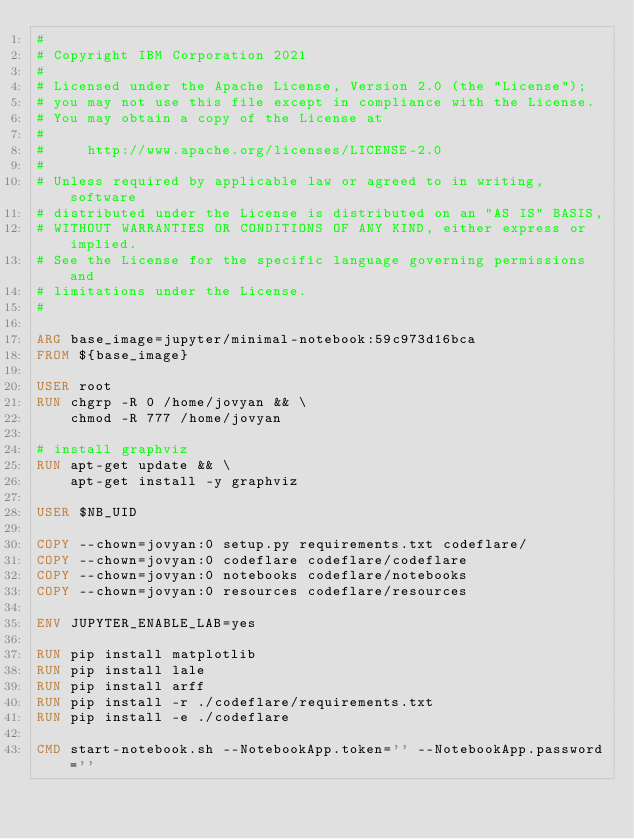Convert code to text. <code><loc_0><loc_0><loc_500><loc_500><_Dockerfile_>#
# Copyright IBM Corporation 2021
#
# Licensed under the Apache License, Version 2.0 (the "License");
# you may not use this file except in compliance with the License.
# You may obtain a copy of the License at
#
#     http://www.apache.org/licenses/LICENSE-2.0
#
# Unless required by applicable law or agreed to in writing, software
# distributed under the License is distributed on an "AS IS" BASIS,
# WITHOUT WARRANTIES OR CONDITIONS OF ANY KIND, either express or implied.
# See the License for the specific language governing permissions and
# limitations under the License.
#

ARG base_image=jupyter/minimal-notebook:59c973d16bca
FROM ${base_image}

USER root
RUN chgrp -R 0 /home/jovyan && \
    chmod -R 777 /home/jovyan

# install graphviz
RUN apt-get update && \
    apt-get install -y graphviz

USER $NB_UID

COPY --chown=jovyan:0 setup.py requirements.txt codeflare/
COPY --chown=jovyan:0 codeflare codeflare/codeflare
COPY --chown=jovyan:0 notebooks codeflare/notebooks
COPY --chown=jovyan:0 resources codeflare/resources

ENV JUPYTER_ENABLE_LAB=yes

RUN pip install matplotlib
RUN pip install lale
RUN pip install arff
RUN pip install -r ./codeflare/requirements.txt
RUN pip install -e ./codeflare

CMD start-notebook.sh --NotebookApp.token='' --NotebookApp.password=''</code> 